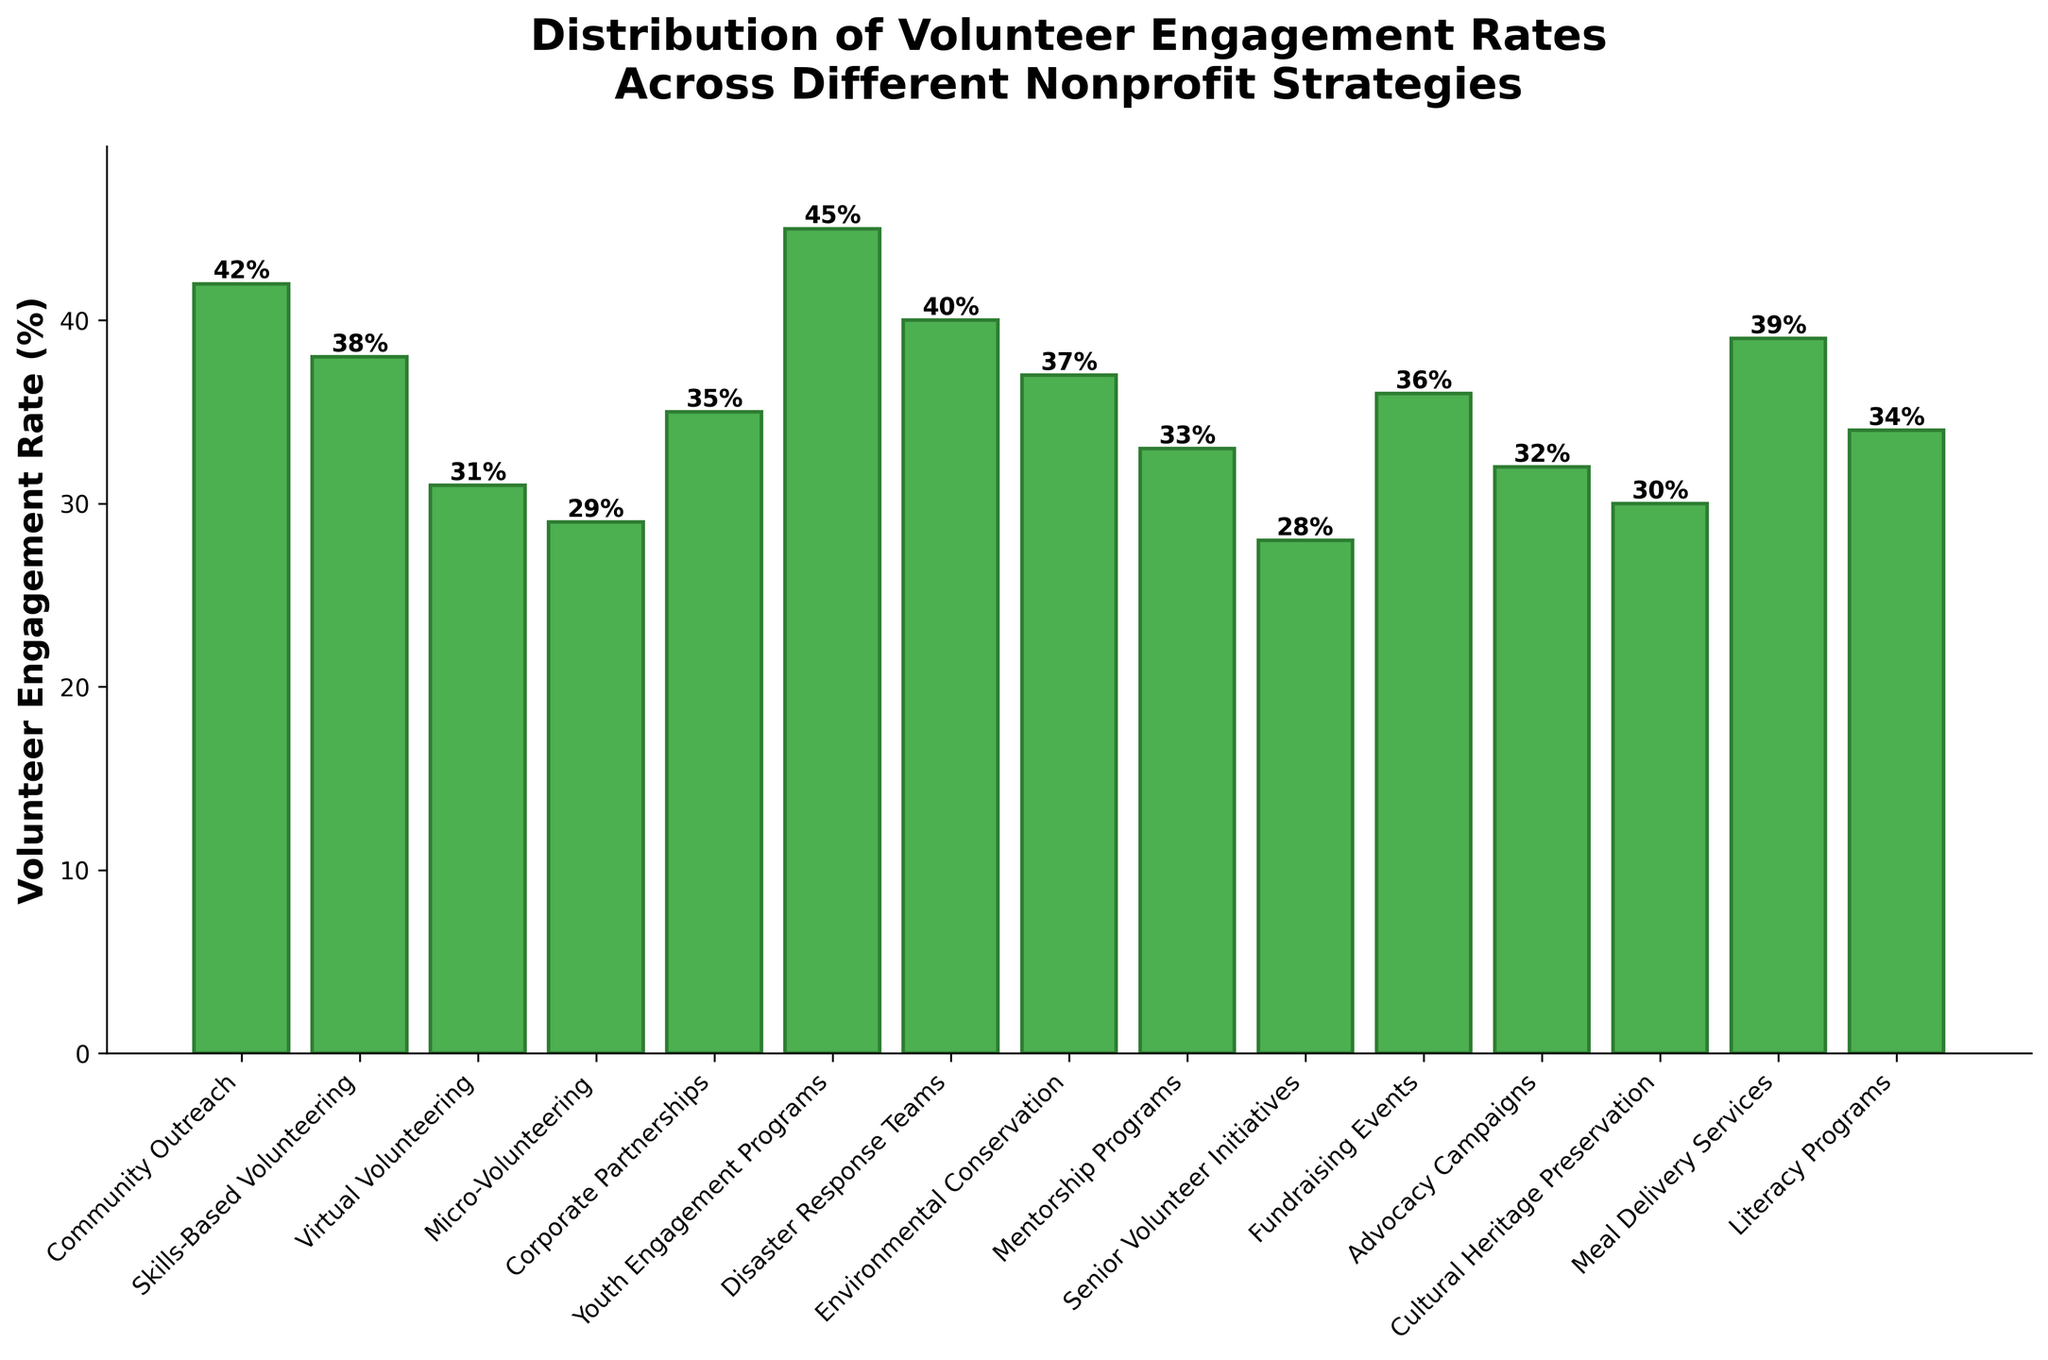What is the strategy with the highest volunteer engagement rate? The strategy with the highest volunteer engagement rate can be identified as the tallest bar in the bar chart. It corresponds to Youth Engagement Programs.
Answer: Youth Engagement Programs What is the difference in engagement rate between the highest and lowest strategies? To find the difference between the highest and lowest engagement rates, subtract the lowest rate (28% for Senior Volunteer Initiatives) from the highest rate (45% for Youth Engagement Programs): 45% - 28% = 17%.
Answer: 17% Which strategies have engagement rates greater than 40%? By examining the bars that exceed the 40% mark on the y-axis, we identify three strategies: Community Outreach (42%), Youth Engagement Programs (45%), and Disaster Response Teams (40%).
Answer: Community Outreach, Youth Engagement Programs, Disaster Response Teams What is the average engagement rate across all strategies? First, sum all the engagement rates: (42 + 38 + 31 + 29 + 35 + 45 + 40 + 37 + 33 + 28 + 36 + 32 + 30 + 39 + 34) = 529. Then, divide by the number of strategies (15): 529 / 15 ≈ 35.27%.
Answer: 35.27% Which strategy has a volunteer engagement rate closest to 33%? Check the bars and their respective heights to find the one closest to 33%. Mentorship Programs has a rate of 33%.
Answer: Mentorship Programs How many strategies have an engagement rate below 35%? Count the bars that have a height below 35%: Micro-Volunteering, Virtual Volunteering, Senior Volunteer Initiatives, Cultural Heritage Preservation, Mentorship Programs, Advocacy Campaigns. There are 6 such strategies.
Answer: 6 How do the top three strategies in terms of engagement rate compare? The top three strategies are Youth Engagement Programs (45%), Community Outreach (42%), and Disaster Response Teams (40%).
Answer: Youth Engagement Programs > Community Outreach > Disaster Response Teams Which strategies have a volunteer engagement rate within 5% of the average? The average engagement rate is approximately 35.27%. Strategies within 5% of this average (30.27% to 40.27%) are Virtual Volunteering (31%), Corporate Partnerships (35%), Environmental Conservation (37%), Fundraising Events (36%), Literacy Programs (34%), Advocacy Campaigns (32%), Meal Delivery Services (39%), and Cultural Heritage Preservation (30%).
Answer: Virtual Volunteering, Corporate Partnerships, Environmental Conservation, Fundraising Events, Literacy Programs, Advocacy Campaigns, Meal Delivery Services, Cultural Heritage Preservation What is the combined engagement rate of Community Outreach and Meal Delivery Services? Add the engagement rates of these two strategies: Community Outreach (42%) + Meal Delivery Services (39%) = 81%.
Answer: 81% 